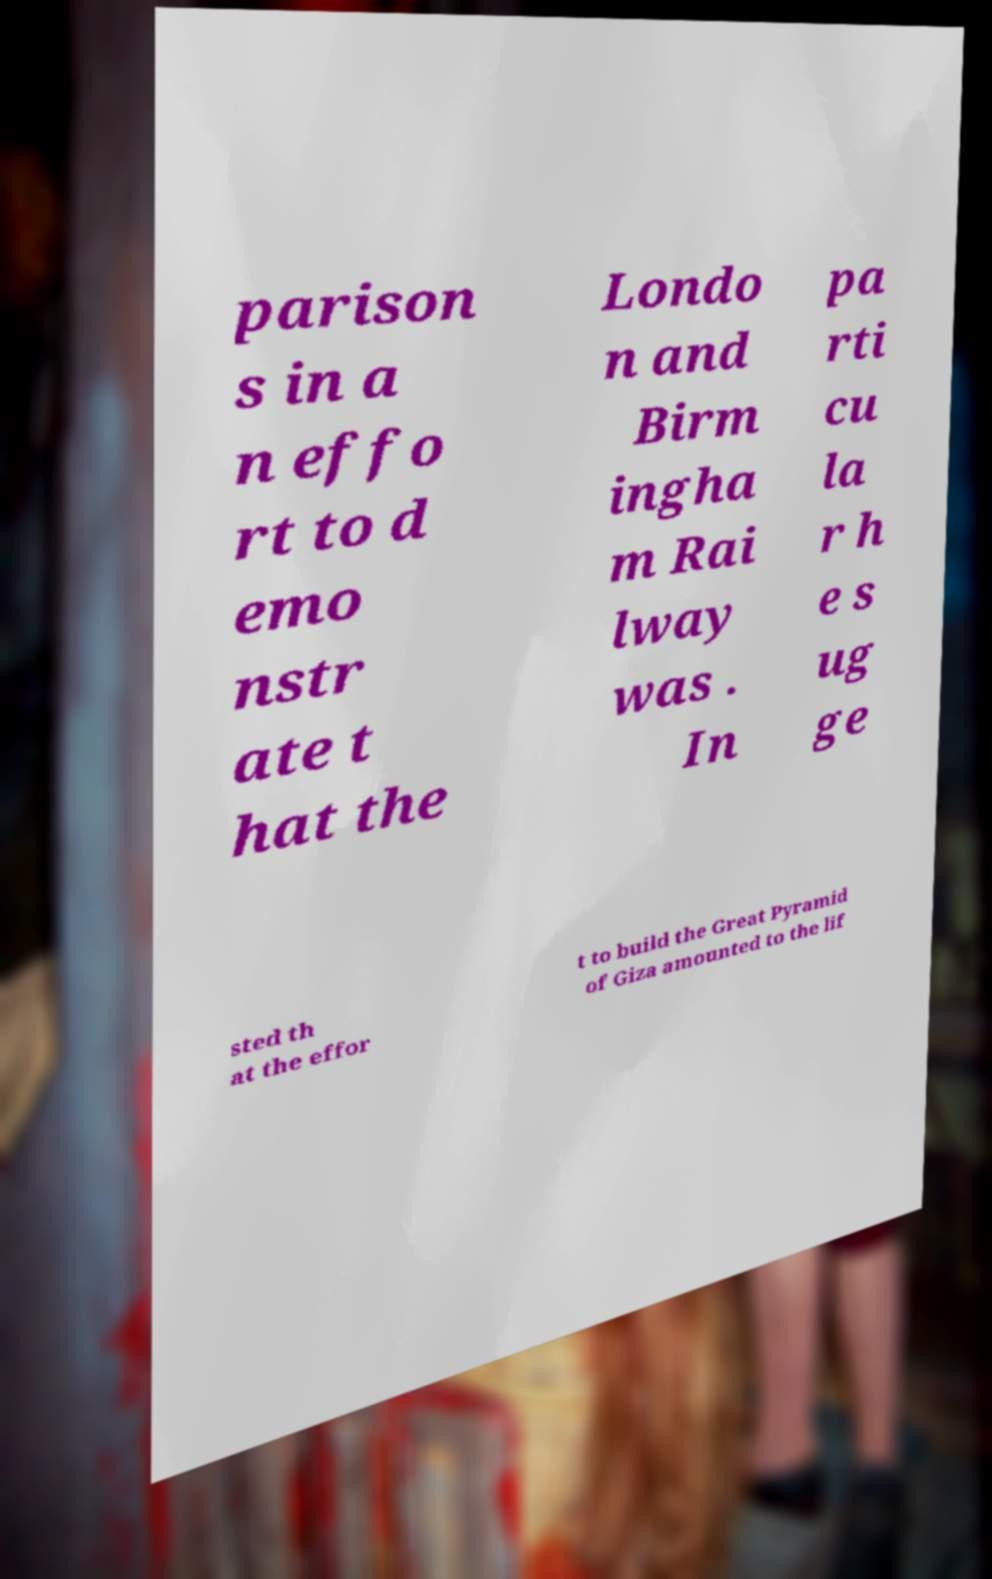Could you assist in decoding the text presented in this image and type it out clearly? parison s in a n effo rt to d emo nstr ate t hat the Londo n and Birm ingha m Rai lway was . In pa rti cu la r h e s ug ge sted th at the effor t to build the Great Pyramid of Giza amounted to the lif 